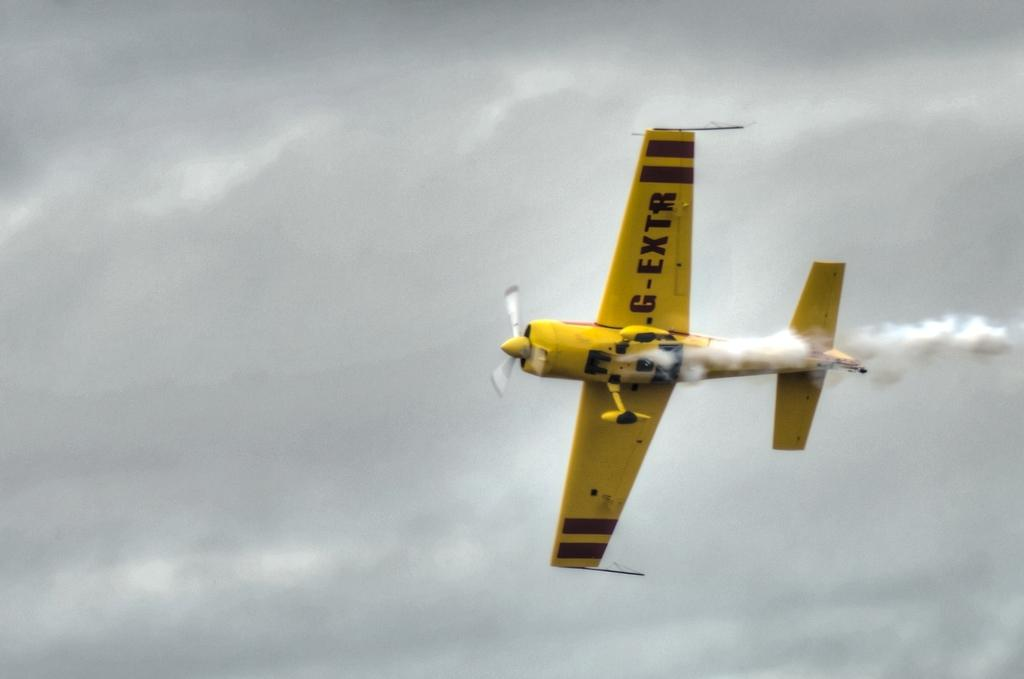<image>
Summarize the visual content of the image. a yellow plane with G-Extr on the wings in in the sky 